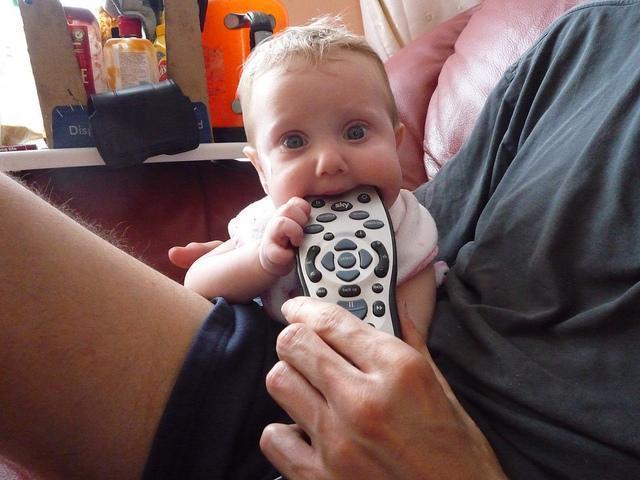What is the baby attempting to eat?
Choose the right answer from the provided options to respond to the question.
Options: Big toe, remote control, apple slices, hot dog. Remote control. 